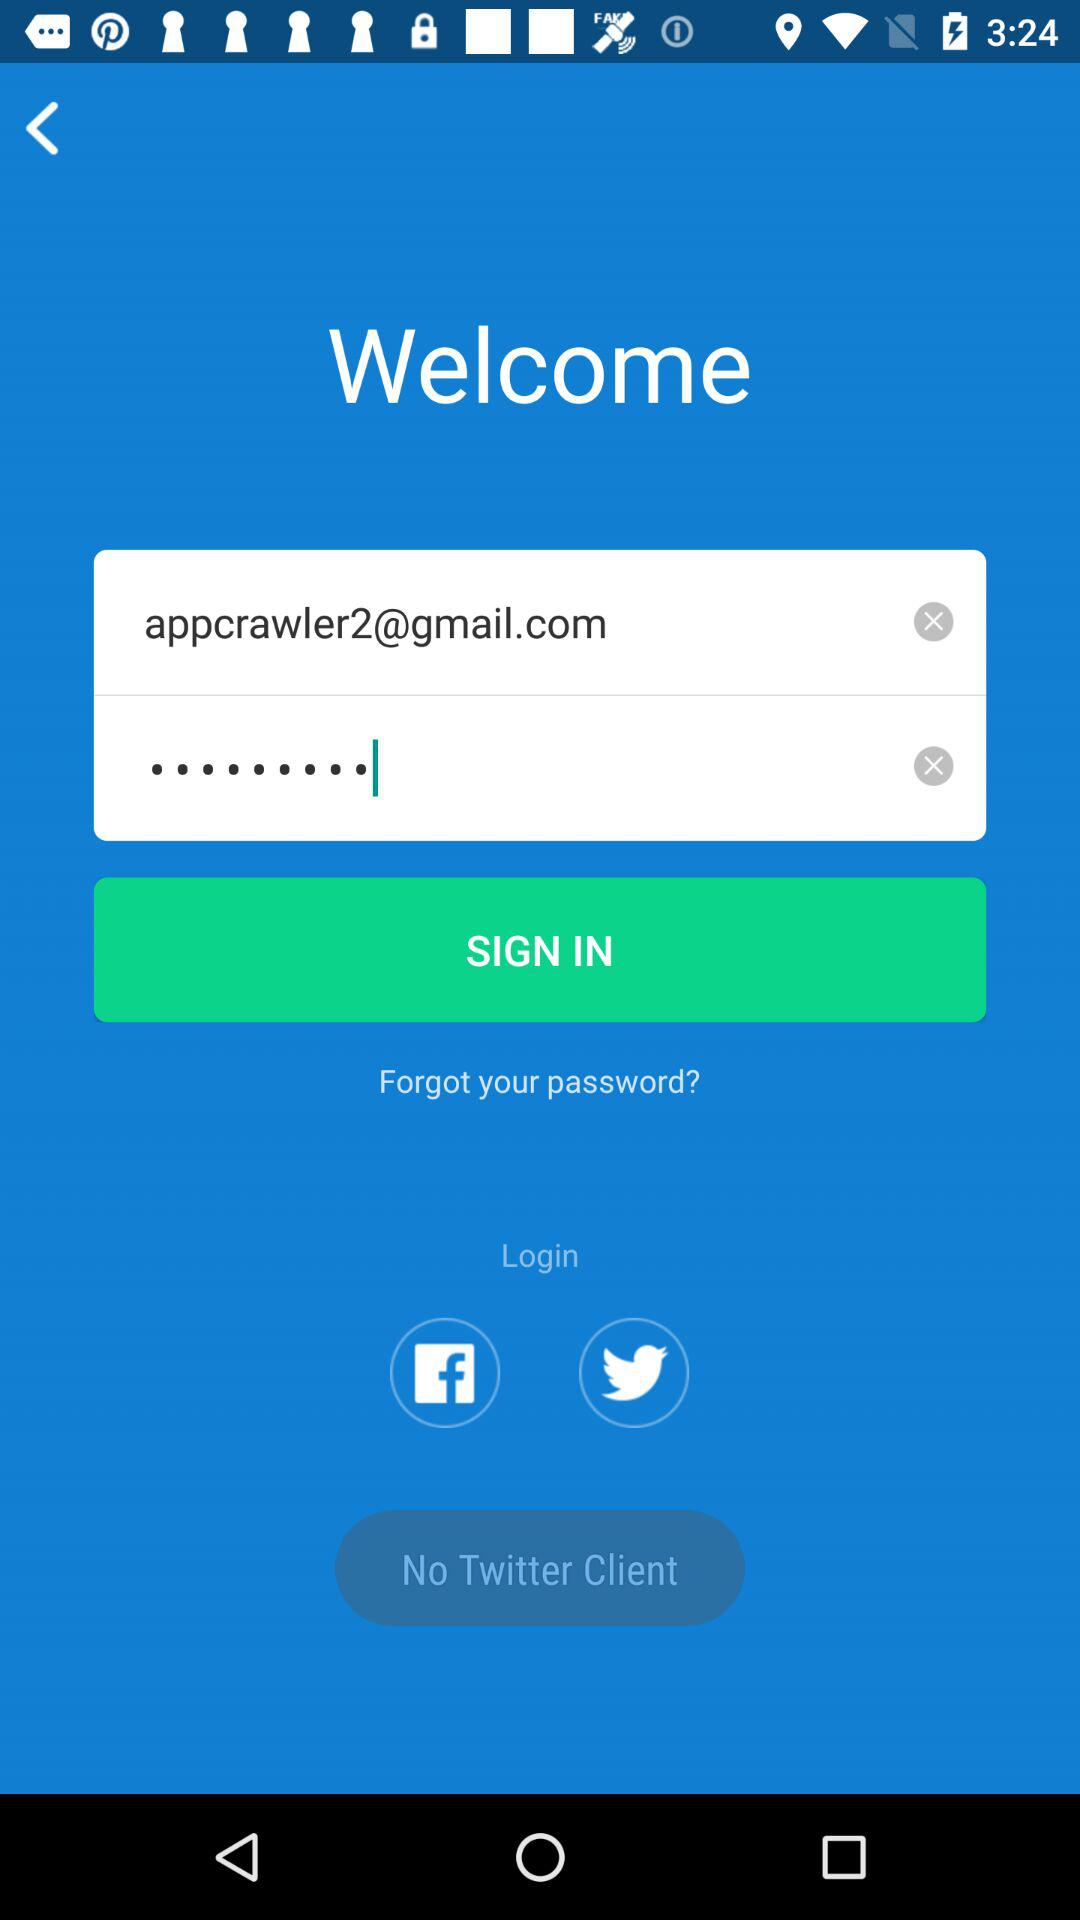What gmail address is used? The email address is appcrawler2@gmail.com. 